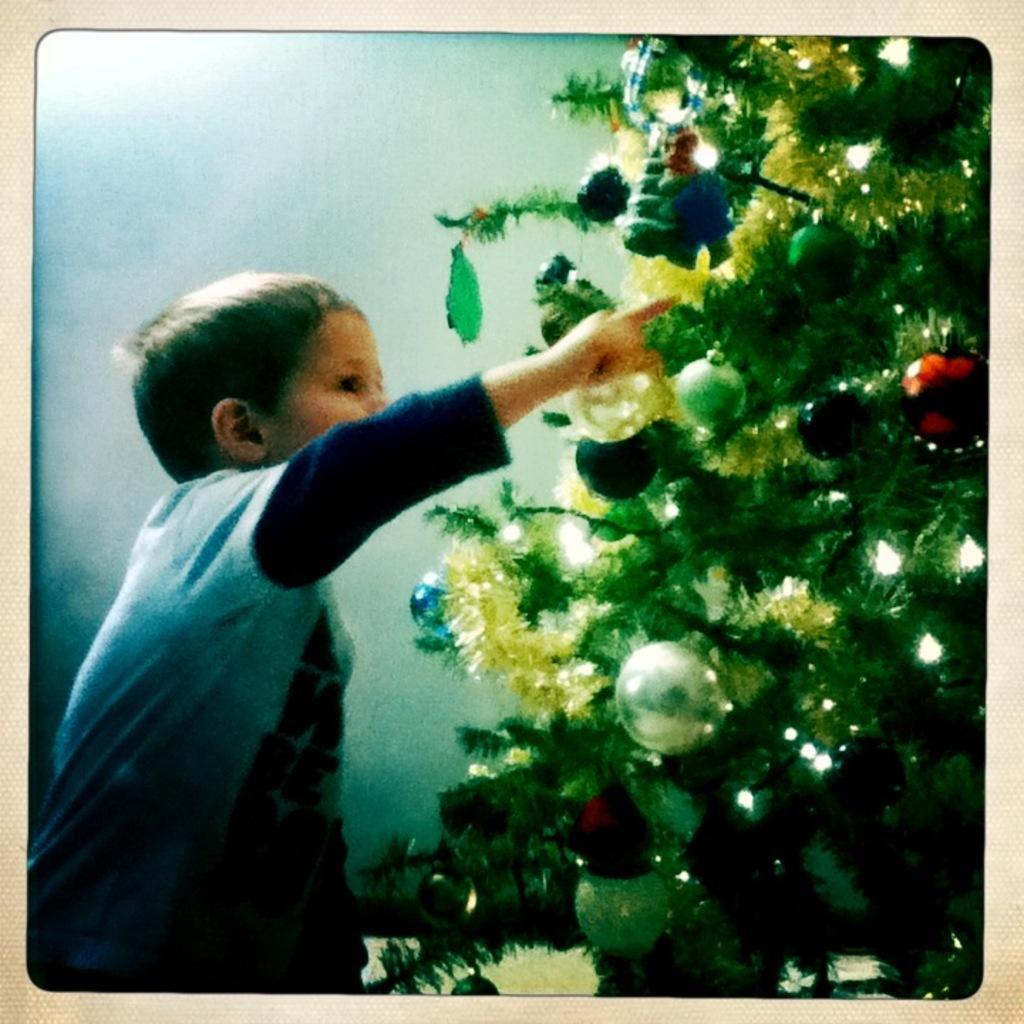Can you describe this image briefly? In this image a boy standing at the Christmas tree. 